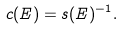<formula> <loc_0><loc_0><loc_500><loc_500>c ( E ) = s ( E ) ^ { - 1 } .</formula> 